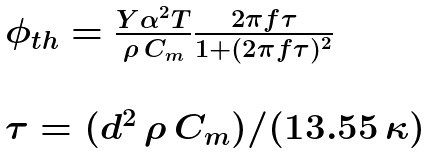<formula> <loc_0><loc_0><loc_500><loc_500>\begin{array} { l } \phi _ { t h } = \frac { Y \alpha ^ { 2 } T } { \rho \, C _ { m } } \frac { 2 \pi f \tau } { 1 + ( 2 \pi f \tau ) ^ { 2 } } \\ \\ \tau = ( d ^ { 2 } \, \rho \, C _ { m } ) / ( 1 3 . 5 5 \, \kappa ) \end{array}</formula> 